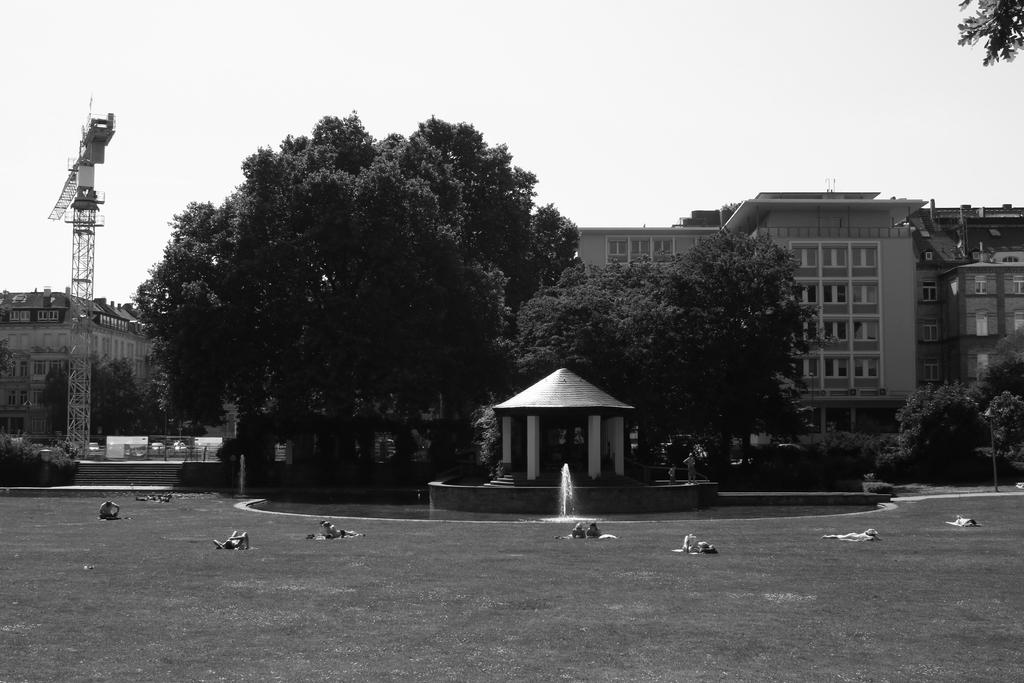What is the color scheme of the image? The image is black and white. What type of natural elements can be seen in the image? There are trees in the image. What type of structure is present in the image? There is a crane tower in the image. What architectural feature is visible in the image? There are steps in the image. What type of water feature is present in the image? There is a water fountain in the image. What type of shelter is present in the image? There is a shelter in the image. What type of man-made structures can be seen in the image? There are buildings in the image. Are there any people present in the image? Yes, there are people in the image. What part of the natural environment is visible in the image? The sky is visible in the image. What other objects can be seen in the image? There are objects in the image. What type of mint can be smelled in the image? There is no mint present in the image, and therefore no scent can be detected. 